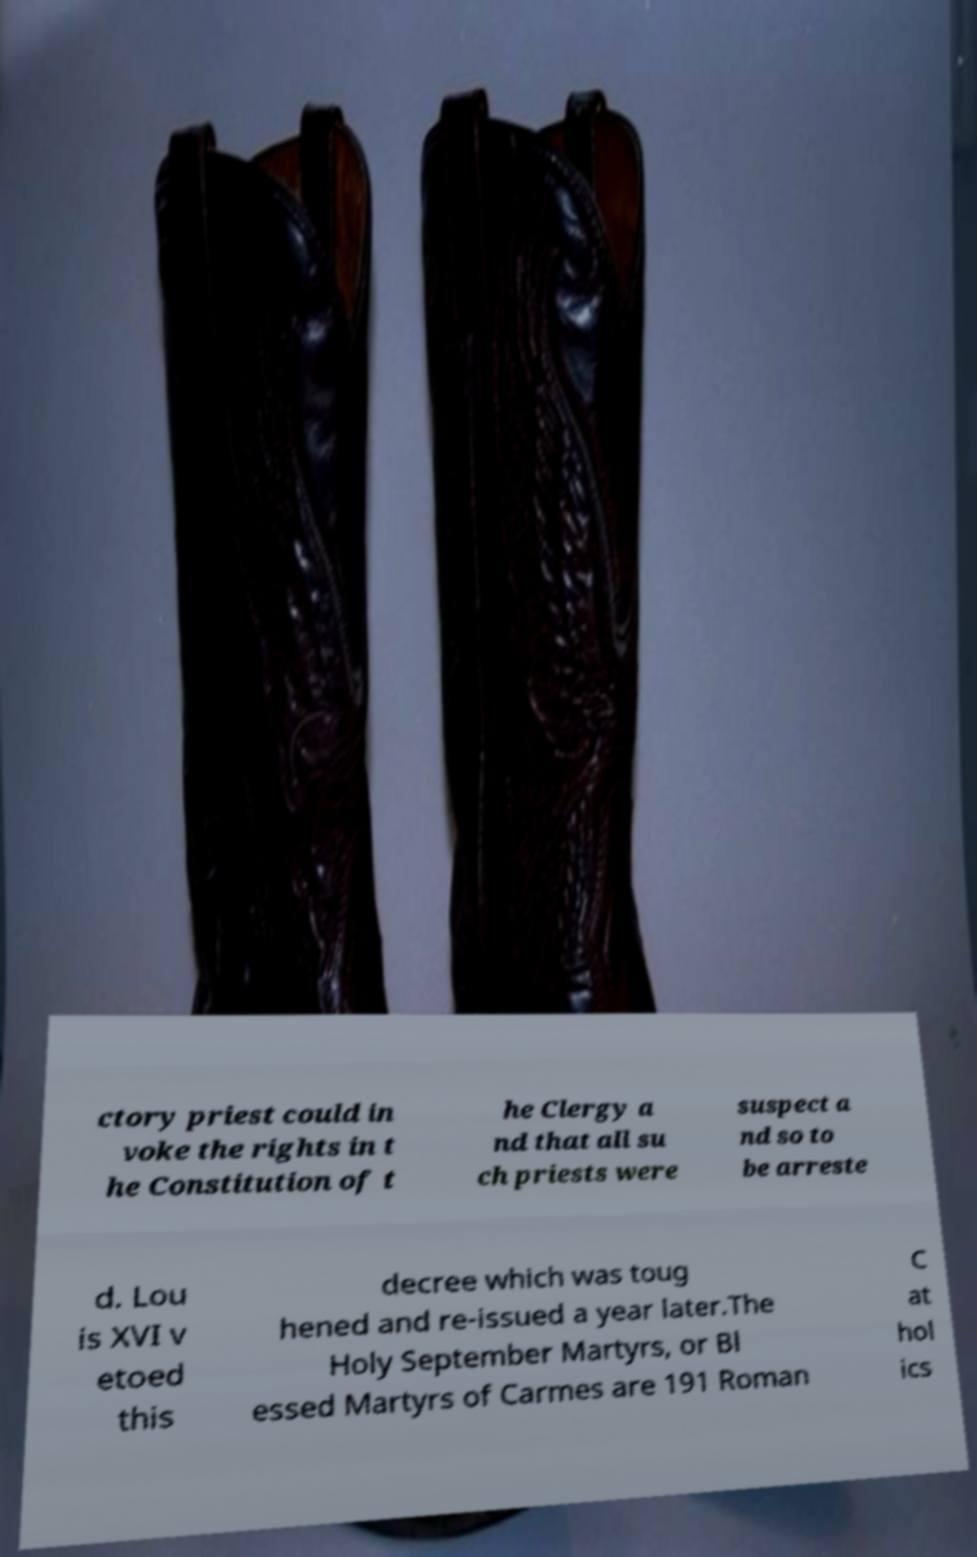There's text embedded in this image that I need extracted. Can you transcribe it verbatim? ctory priest could in voke the rights in t he Constitution of t he Clergy a nd that all su ch priests were suspect a nd so to be arreste d. Lou is XVI v etoed this decree which was toug hened and re-issued a year later.The Holy September Martyrs, or Bl essed Martyrs of Carmes are 191 Roman C at hol ics 